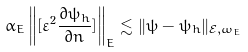<formula> <loc_0><loc_0><loc_500><loc_500>\alpha _ { E } \left \| [ \varepsilon ^ { 2 } \frac { \partial \psi _ { h } } { \partial { n } } ] \right \| _ { E } \lesssim \| \psi - \psi _ { h } \| _ { \mathcal { E } , \omega _ { E } }</formula> 